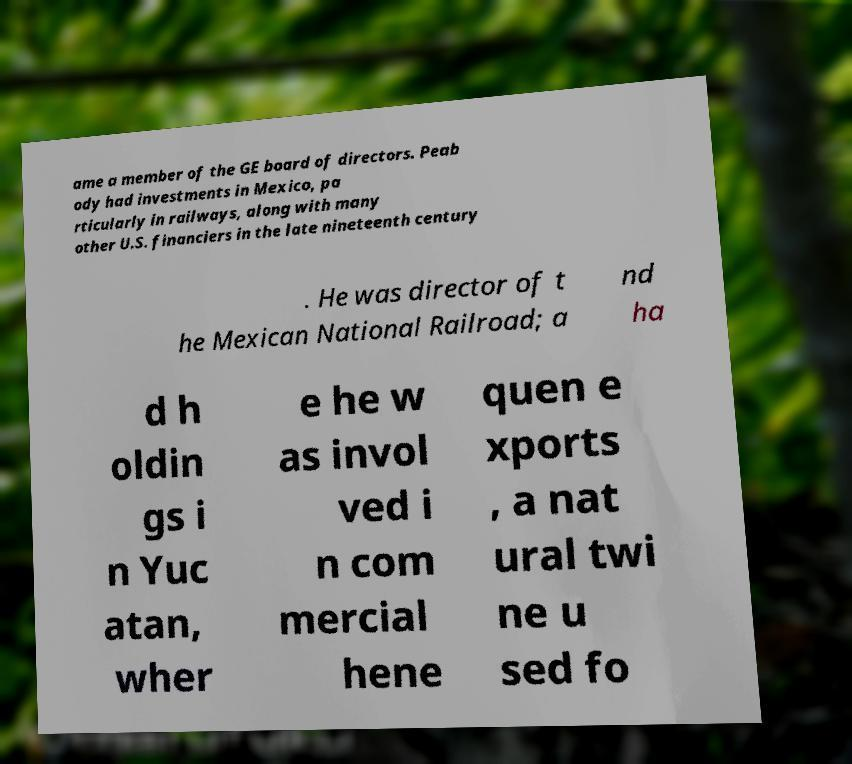Could you extract and type out the text from this image? ame a member of the GE board of directors. Peab ody had investments in Mexico, pa rticularly in railways, along with many other U.S. financiers in the late nineteenth century . He was director of t he Mexican National Railroad; a nd ha d h oldin gs i n Yuc atan, wher e he w as invol ved i n com mercial hene quen e xports , a nat ural twi ne u sed fo 